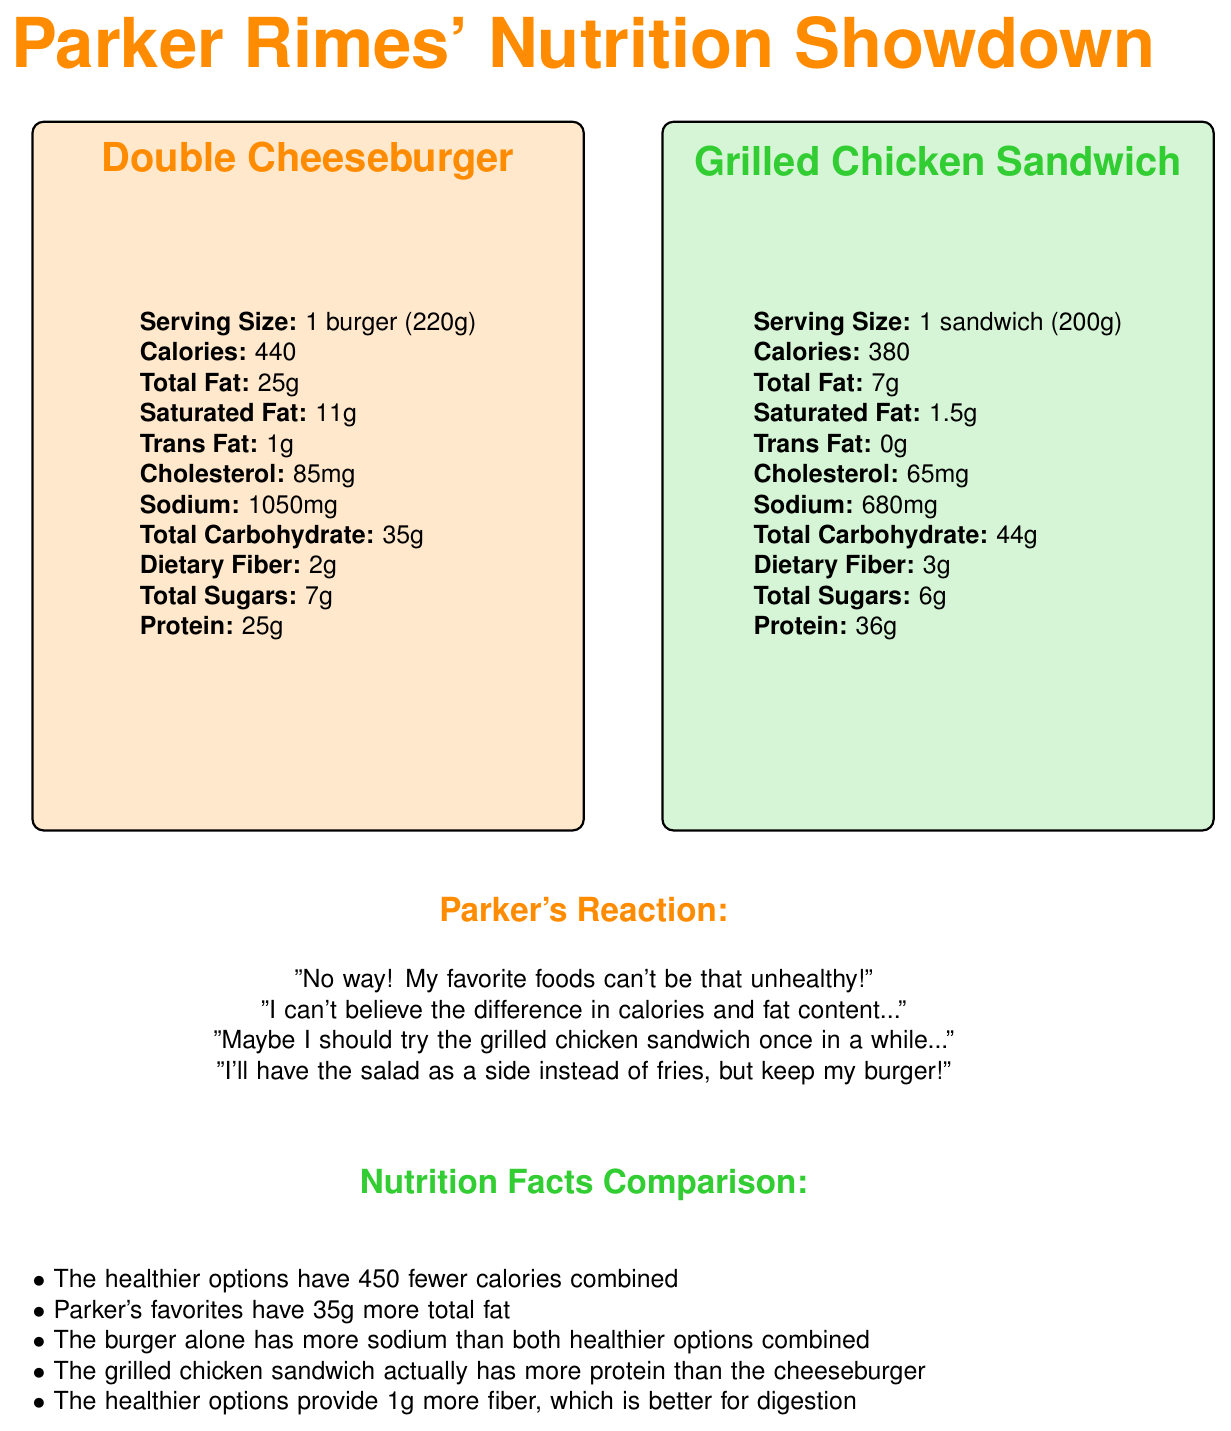what is the serving size for Parker Rimes' favorite Double Cheeseburger? The document states the serving size for the Double Cheeseburger is 1 burger with a weight of 220g.
Answer: 1 burger (220g) which food has more calories, Parker's favorite Large French Fries or the healthier Side Salad with Balsamic Vinaigrette? The Large French Fries have 510 calories whereas the Side Salad with Balsamic Vinaigrette has only 120 calories.
Answer: Large French Fries how much more protein does the Grilled Chicken Sandwich have compared to the Double Cheeseburger? The Grilled Chicken Sandwich has 36g of protein while the Double Cheeseburger has 25g of protein, making it 11g more.
Answer: 11g more what is Parker Rimes' reaction when he realized the difference in calories and fat content? Parker's reaction is outlined in the section titled "Parker’s Reaction."
Answer: "I can't believe the difference in calories and fat content…" which food has the least amount of sodium? A. Double Cheeseburger B. Large French Fries C. Grilled Chicken Sandwich D. Side Salad with Balsamic Vinaigrette The Side Salad with Balsamic Vinaigrette has 280mg of sodium, which is the least compared to the other options.
Answer: D. Side Salad with Balsamic Vinaigrette which food provides more dietary fiber? A. Double Cheeseburger B. Large French Fries C. Grilled Chicken Sandwich D. Side Salad with Balsamic Vinaigrette Large French Fries provide 5g of dietary fiber, which is higher than the other options.
Answer: B. Large French Fries does the Grilled Chicken Sandwich have any trans fat? The document specifies that the Grilled Chicken Sandwich has 0g of trans fat.
Answer: No summarize the main idea of the document. The document title "Parker Rimes' Nutrition Showdown," visual labels, and various data comparisons between favorite and healthier foods describe nutritional insights and show Parker's reactions to the differences.
Answer: The document compares Parker Rimes' favorite foods with healthier alternatives highlighting nutritional differences, Parker's reactions, and the nutritional facts comparison. how much iron is found in the Side Salad with Balsamic Vinaigrette? The document lists iron content for the Side Salad with Balsamic Vinaigrette as 1mg.
Answer: 1mg does the Double Cheeseburger or the healthier Grilled Chicken Sandwich have more cholesterol? The Double Cheeseburger has 85mg of cholesterol, while the Grilled Chicken Sandwich has 65mg.
Answer: Double Cheeseburger what is the combined calorie difference between Parker Rimes' favorites and the healthier alternatives? The document mentions that the healthier options have 450 fewer calories combined.
Answer: 450 fewer calories how much calcium does the Large French Fries provide? The document indicates that Large French Fries have a calcium content of 20mg.
Answer: 20mg compare sodium content of Double Cheeseburger vs. both healthier options combined. The Double Cheeseburger alone has 1050mg of sodium, while a combination of the Grilled Chicken Sandwich (680mg) and Side Salad with Balsamic Vinaigrette (280mg) totals 960mg, which is still less than the burger's sodium content.
Answer: Double Cheeseburger has more how much total carbohydrate does the Side Salad with Balsamic Vinaigrette contain? The document shows that the Side Salad with Balsamic Vinaigrette contains 13g of total carbohydrate.
Answer: 13g if Parker keeps his burger and switches fries for the salad, how many calories would he save? By switching Large French Fries (510 calories) with the Side Salad with Balsamic Vinaigrette (120 calories), Parker would save 390 calories.
Answer: 390 which food offers more potassium? A. Double Cheeseburger B. Large French Fries C. Grilled Chicken Sandwich D. Side Salad with Balsamic Vinaigrette The Large French Fries offer 720mg of potassium, which is more compared to the other options.
Answer: B. Large French Fries what additional nutrients are mentioned in the comparison section besides calories and fat? The nutrition facts comparison mentions calories, total fat, sodium, protein, and dietary fiber.
Answer: Sodium, Protein, Dietary Fiber what is Parker's final compromise mentioned in his reaction? Parker's final compromise is to keep his burger but have the salad as a side instead of fries.
Answer: Keeping the burger and having the salad instead of fries does the document specify the brand or restaurant of these foods? The document does not provide any information about the brand or restaurant for these foods.
Answer: Cannot be determined which food has the highest amount of saturated fat? A. Double Cheeseburger B. Large French Fries C. Grilled Chicken Sandwich D. Side Salad with Balsamic Vinaigrette The Double Cheeseburger has 11g of saturated fat, the highest among the given options.
Answer: A. Double Cheeseburger 